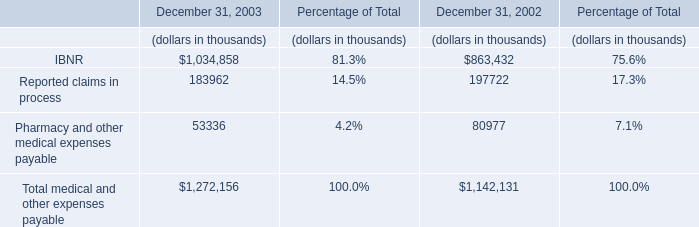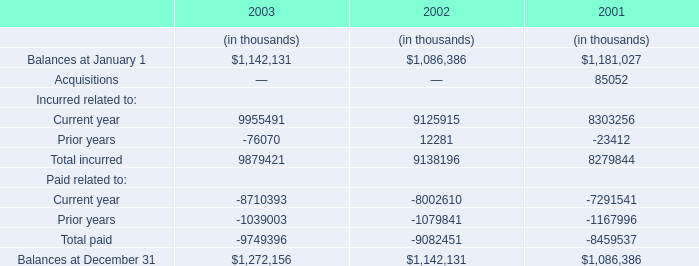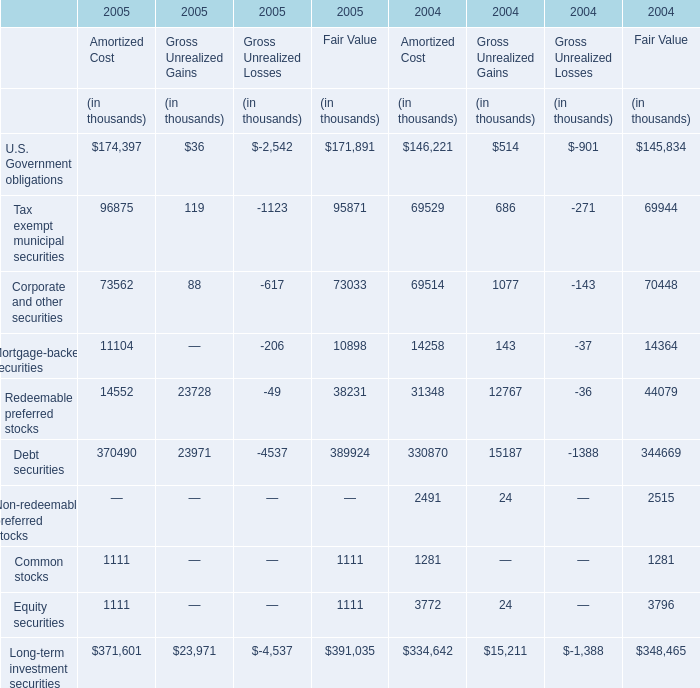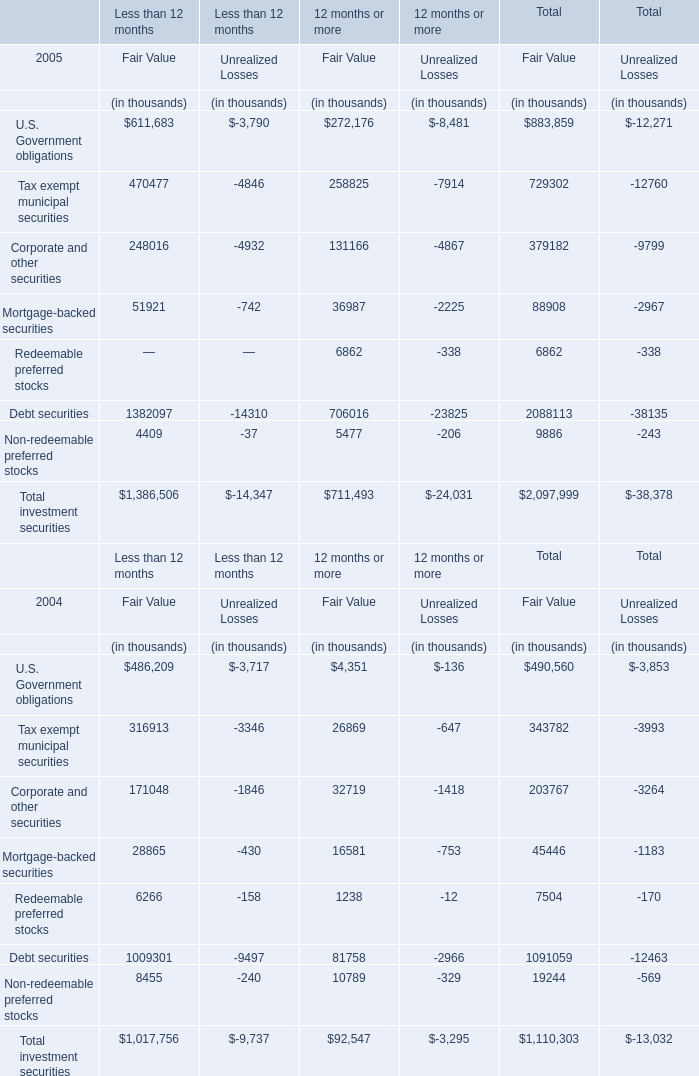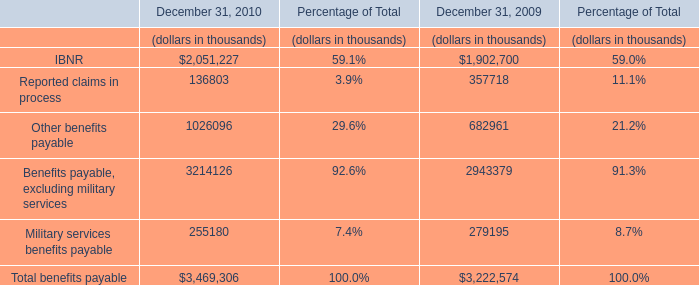What's the current increasing rate of U.S. Government obligations for Fair Value of Total? 
Computations: ((883859 - 490560) / 490560)
Answer: 0.80173. 